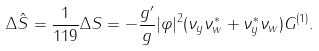<formula> <loc_0><loc_0><loc_500><loc_500>\Delta \hat { S } = \frac { 1 } { 1 1 9 } \Delta S = - \frac { g ^ { \prime } } { g } | \varphi | ^ { 2 } ( \nu _ { y } \nu ^ { * } _ { w } + \nu ^ { * } _ { y } \nu _ { w } ) G ^ { ( 1 ) } .</formula> 